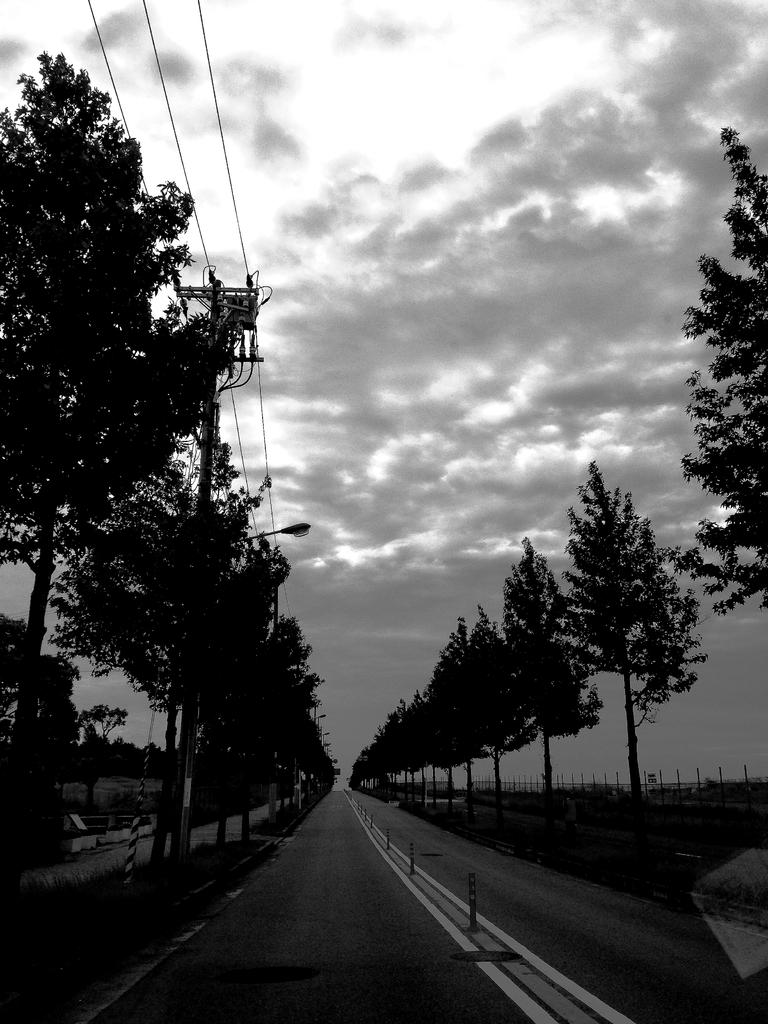What type of vegetation can be seen on both sides of the image? There are trees on the right side and the left side of the image. What structure is located on the left side of the image? There is a pole on the left side of the image. What is attached to the pole on the left side of the image? There is a light on the left side of the image, and it is attached to the pole. What else can be seen on the left side of the image? There are wires on the left side of the image. What is visible at the top of the image? The sky is visible at the top of the image. What can be seen in the sky? Clouds are present in the sky. What type of hot wire can be seen in the image? There is no hot wire present in the image. What type of field is visible in the image? There is no field visible in the image. 